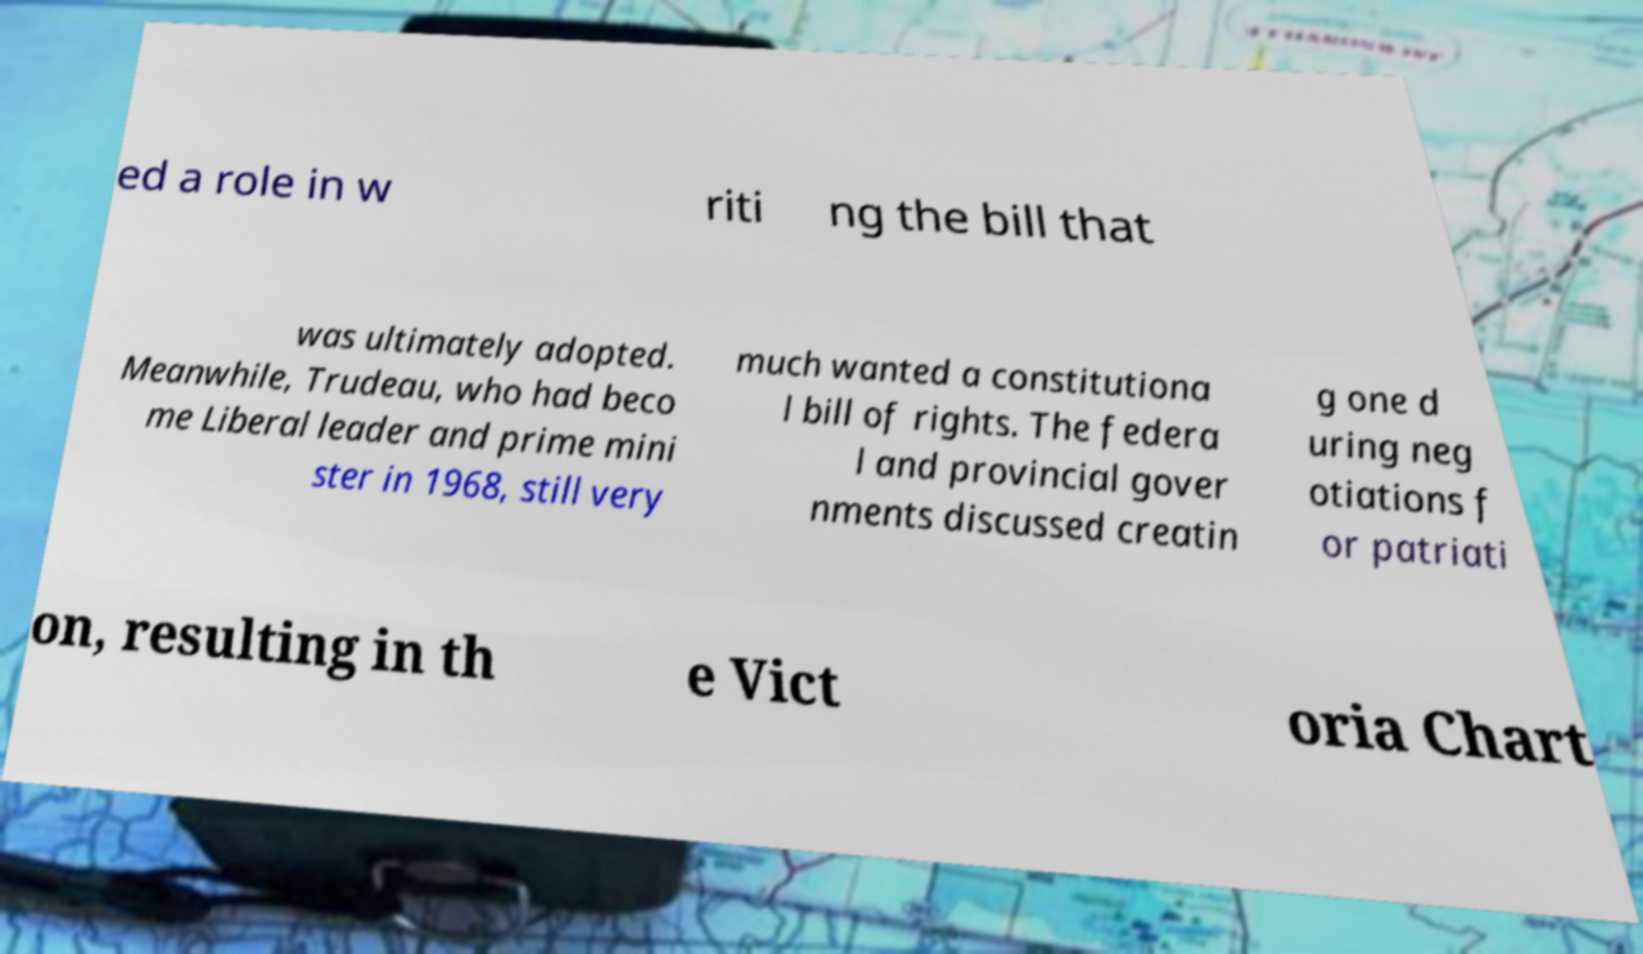Can you read and provide the text displayed in the image?This photo seems to have some interesting text. Can you extract and type it out for me? ed a role in w riti ng the bill that was ultimately adopted. Meanwhile, Trudeau, who had beco me Liberal leader and prime mini ster in 1968, still very much wanted a constitutiona l bill of rights. The federa l and provincial gover nments discussed creatin g one d uring neg otiations f or patriati on, resulting in th e Vict oria Chart 